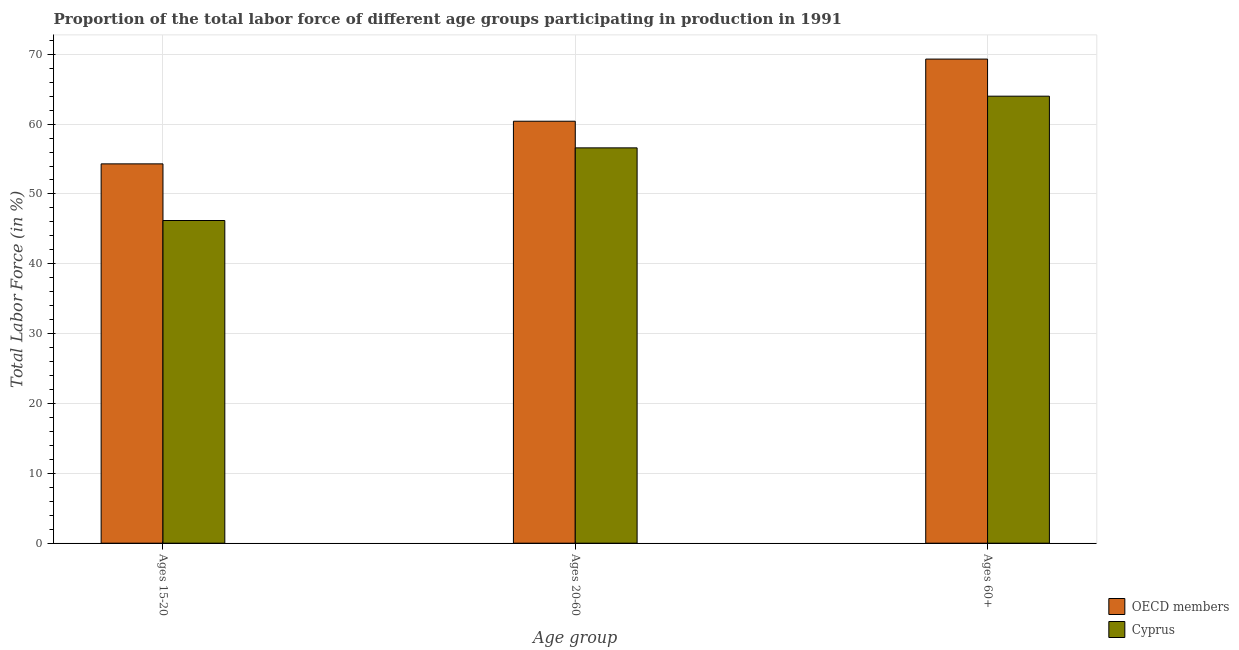How many different coloured bars are there?
Ensure brevity in your answer.  2. How many groups of bars are there?
Your response must be concise. 3. Are the number of bars per tick equal to the number of legend labels?
Offer a very short reply. Yes. Are the number of bars on each tick of the X-axis equal?
Provide a succinct answer. Yes. How many bars are there on the 3rd tick from the right?
Offer a very short reply. 2. What is the label of the 1st group of bars from the left?
Make the answer very short. Ages 15-20. What is the percentage of labor force within the age group 15-20 in OECD members?
Offer a terse response. 54.31. Across all countries, what is the maximum percentage of labor force within the age group 20-60?
Provide a short and direct response. 60.41. In which country was the percentage of labor force above age 60 minimum?
Offer a terse response. Cyprus. What is the total percentage of labor force within the age group 15-20 in the graph?
Keep it short and to the point. 100.51. What is the difference between the percentage of labor force above age 60 in Cyprus and that in OECD members?
Your answer should be compact. -5.31. What is the difference between the percentage of labor force above age 60 in Cyprus and the percentage of labor force within the age group 20-60 in OECD members?
Your answer should be very brief. 3.59. What is the average percentage of labor force above age 60 per country?
Your answer should be very brief. 66.66. What is the difference between the percentage of labor force within the age group 15-20 and percentage of labor force above age 60 in OECD members?
Offer a terse response. -15. In how many countries, is the percentage of labor force within the age group 15-20 greater than 24 %?
Provide a succinct answer. 2. What is the ratio of the percentage of labor force within the age group 15-20 in Cyprus to that in OECD members?
Provide a succinct answer. 0.85. Is the percentage of labor force within the age group 20-60 in OECD members less than that in Cyprus?
Make the answer very short. No. Is the difference between the percentage of labor force within the age group 20-60 in OECD members and Cyprus greater than the difference between the percentage of labor force above age 60 in OECD members and Cyprus?
Provide a succinct answer. No. What is the difference between the highest and the second highest percentage of labor force above age 60?
Offer a terse response. 5.31. What is the difference between the highest and the lowest percentage of labor force above age 60?
Give a very brief answer. 5.31. Is the sum of the percentage of labor force within the age group 20-60 in OECD members and Cyprus greater than the maximum percentage of labor force above age 60 across all countries?
Make the answer very short. Yes. What does the 2nd bar from the left in Ages 20-60 represents?
Offer a terse response. Cyprus. What does the 2nd bar from the right in Ages 15-20 represents?
Provide a succinct answer. OECD members. Is it the case that in every country, the sum of the percentage of labor force within the age group 15-20 and percentage of labor force within the age group 20-60 is greater than the percentage of labor force above age 60?
Ensure brevity in your answer.  Yes. How many bars are there?
Give a very brief answer. 6. Does the graph contain any zero values?
Your answer should be compact. No. Does the graph contain grids?
Your answer should be compact. Yes. How many legend labels are there?
Make the answer very short. 2. What is the title of the graph?
Provide a succinct answer. Proportion of the total labor force of different age groups participating in production in 1991. What is the label or title of the X-axis?
Provide a short and direct response. Age group. What is the label or title of the Y-axis?
Provide a succinct answer. Total Labor Force (in %). What is the Total Labor Force (in %) in OECD members in Ages 15-20?
Give a very brief answer. 54.31. What is the Total Labor Force (in %) of Cyprus in Ages 15-20?
Your answer should be compact. 46.2. What is the Total Labor Force (in %) of OECD members in Ages 20-60?
Provide a succinct answer. 60.41. What is the Total Labor Force (in %) in Cyprus in Ages 20-60?
Offer a terse response. 56.6. What is the Total Labor Force (in %) in OECD members in Ages 60+?
Your response must be concise. 69.31. What is the Total Labor Force (in %) in Cyprus in Ages 60+?
Keep it short and to the point. 64. Across all Age group, what is the maximum Total Labor Force (in %) in OECD members?
Provide a short and direct response. 69.31. Across all Age group, what is the minimum Total Labor Force (in %) of OECD members?
Offer a terse response. 54.31. Across all Age group, what is the minimum Total Labor Force (in %) in Cyprus?
Give a very brief answer. 46.2. What is the total Total Labor Force (in %) of OECD members in the graph?
Your response must be concise. 184.03. What is the total Total Labor Force (in %) in Cyprus in the graph?
Ensure brevity in your answer.  166.8. What is the difference between the Total Labor Force (in %) of OECD members in Ages 15-20 and that in Ages 20-60?
Your response must be concise. -6.1. What is the difference between the Total Labor Force (in %) in Cyprus in Ages 15-20 and that in Ages 20-60?
Give a very brief answer. -10.4. What is the difference between the Total Labor Force (in %) in OECD members in Ages 15-20 and that in Ages 60+?
Keep it short and to the point. -15. What is the difference between the Total Labor Force (in %) in Cyprus in Ages 15-20 and that in Ages 60+?
Make the answer very short. -17.8. What is the difference between the Total Labor Force (in %) in OECD members in Ages 20-60 and that in Ages 60+?
Provide a succinct answer. -8.9. What is the difference between the Total Labor Force (in %) of OECD members in Ages 15-20 and the Total Labor Force (in %) of Cyprus in Ages 20-60?
Give a very brief answer. -2.29. What is the difference between the Total Labor Force (in %) in OECD members in Ages 15-20 and the Total Labor Force (in %) in Cyprus in Ages 60+?
Your answer should be very brief. -9.69. What is the difference between the Total Labor Force (in %) of OECD members in Ages 20-60 and the Total Labor Force (in %) of Cyprus in Ages 60+?
Make the answer very short. -3.59. What is the average Total Labor Force (in %) of OECD members per Age group?
Your answer should be compact. 61.34. What is the average Total Labor Force (in %) in Cyprus per Age group?
Provide a short and direct response. 55.6. What is the difference between the Total Labor Force (in %) in OECD members and Total Labor Force (in %) in Cyprus in Ages 15-20?
Keep it short and to the point. 8.11. What is the difference between the Total Labor Force (in %) of OECD members and Total Labor Force (in %) of Cyprus in Ages 20-60?
Provide a succinct answer. 3.81. What is the difference between the Total Labor Force (in %) in OECD members and Total Labor Force (in %) in Cyprus in Ages 60+?
Your answer should be compact. 5.31. What is the ratio of the Total Labor Force (in %) of OECD members in Ages 15-20 to that in Ages 20-60?
Ensure brevity in your answer.  0.9. What is the ratio of the Total Labor Force (in %) in Cyprus in Ages 15-20 to that in Ages 20-60?
Your answer should be very brief. 0.82. What is the ratio of the Total Labor Force (in %) of OECD members in Ages 15-20 to that in Ages 60+?
Give a very brief answer. 0.78. What is the ratio of the Total Labor Force (in %) in Cyprus in Ages 15-20 to that in Ages 60+?
Make the answer very short. 0.72. What is the ratio of the Total Labor Force (in %) of OECD members in Ages 20-60 to that in Ages 60+?
Keep it short and to the point. 0.87. What is the ratio of the Total Labor Force (in %) in Cyprus in Ages 20-60 to that in Ages 60+?
Your response must be concise. 0.88. What is the difference between the highest and the second highest Total Labor Force (in %) of OECD members?
Provide a succinct answer. 8.9. What is the difference between the highest and the lowest Total Labor Force (in %) in OECD members?
Offer a very short reply. 15. What is the difference between the highest and the lowest Total Labor Force (in %) in Cyprus?
Offer a very short reply. 17.8. 